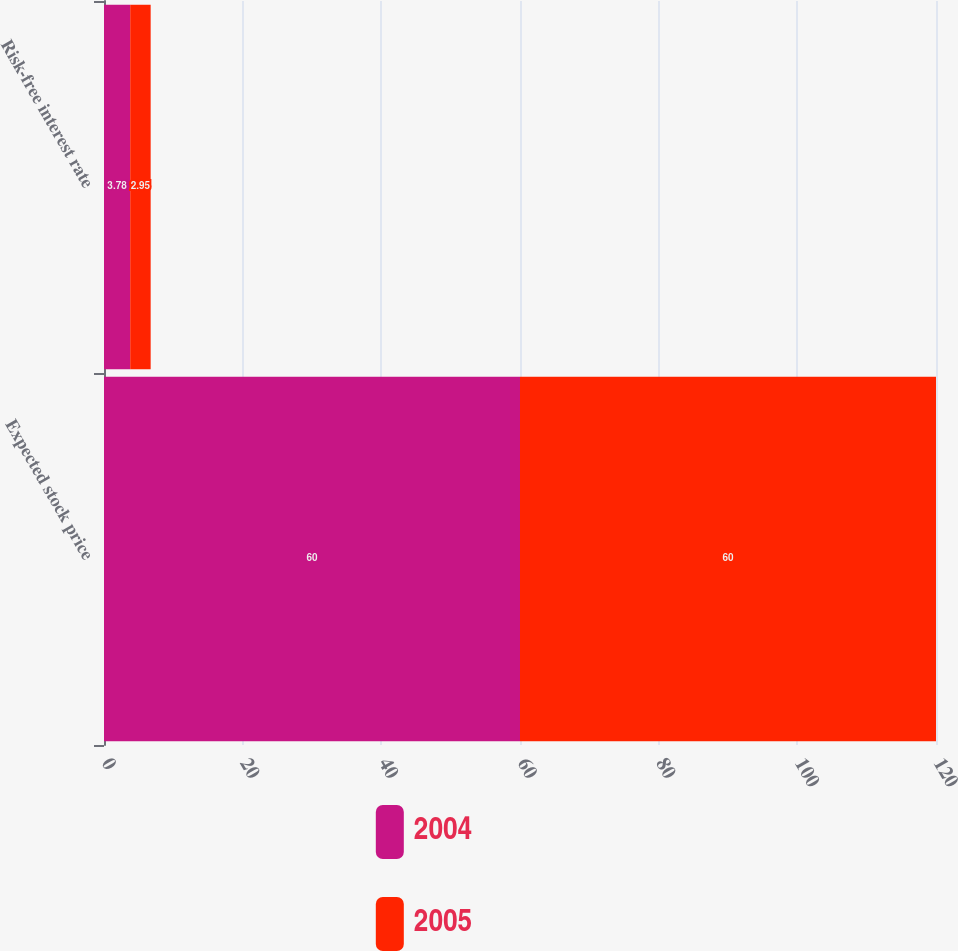Convert chart. <chart><loc_0><loc_0><loc_500><loc_500><stacked_bar_chart><ecel><fcel>Expected stock price<fcel>Risk-free interest rate<nl><fcel>2004<fcel>60<fcel>3.78<nl><fcel>2005<fcel>60<fcel>2.95<nl></chart> 